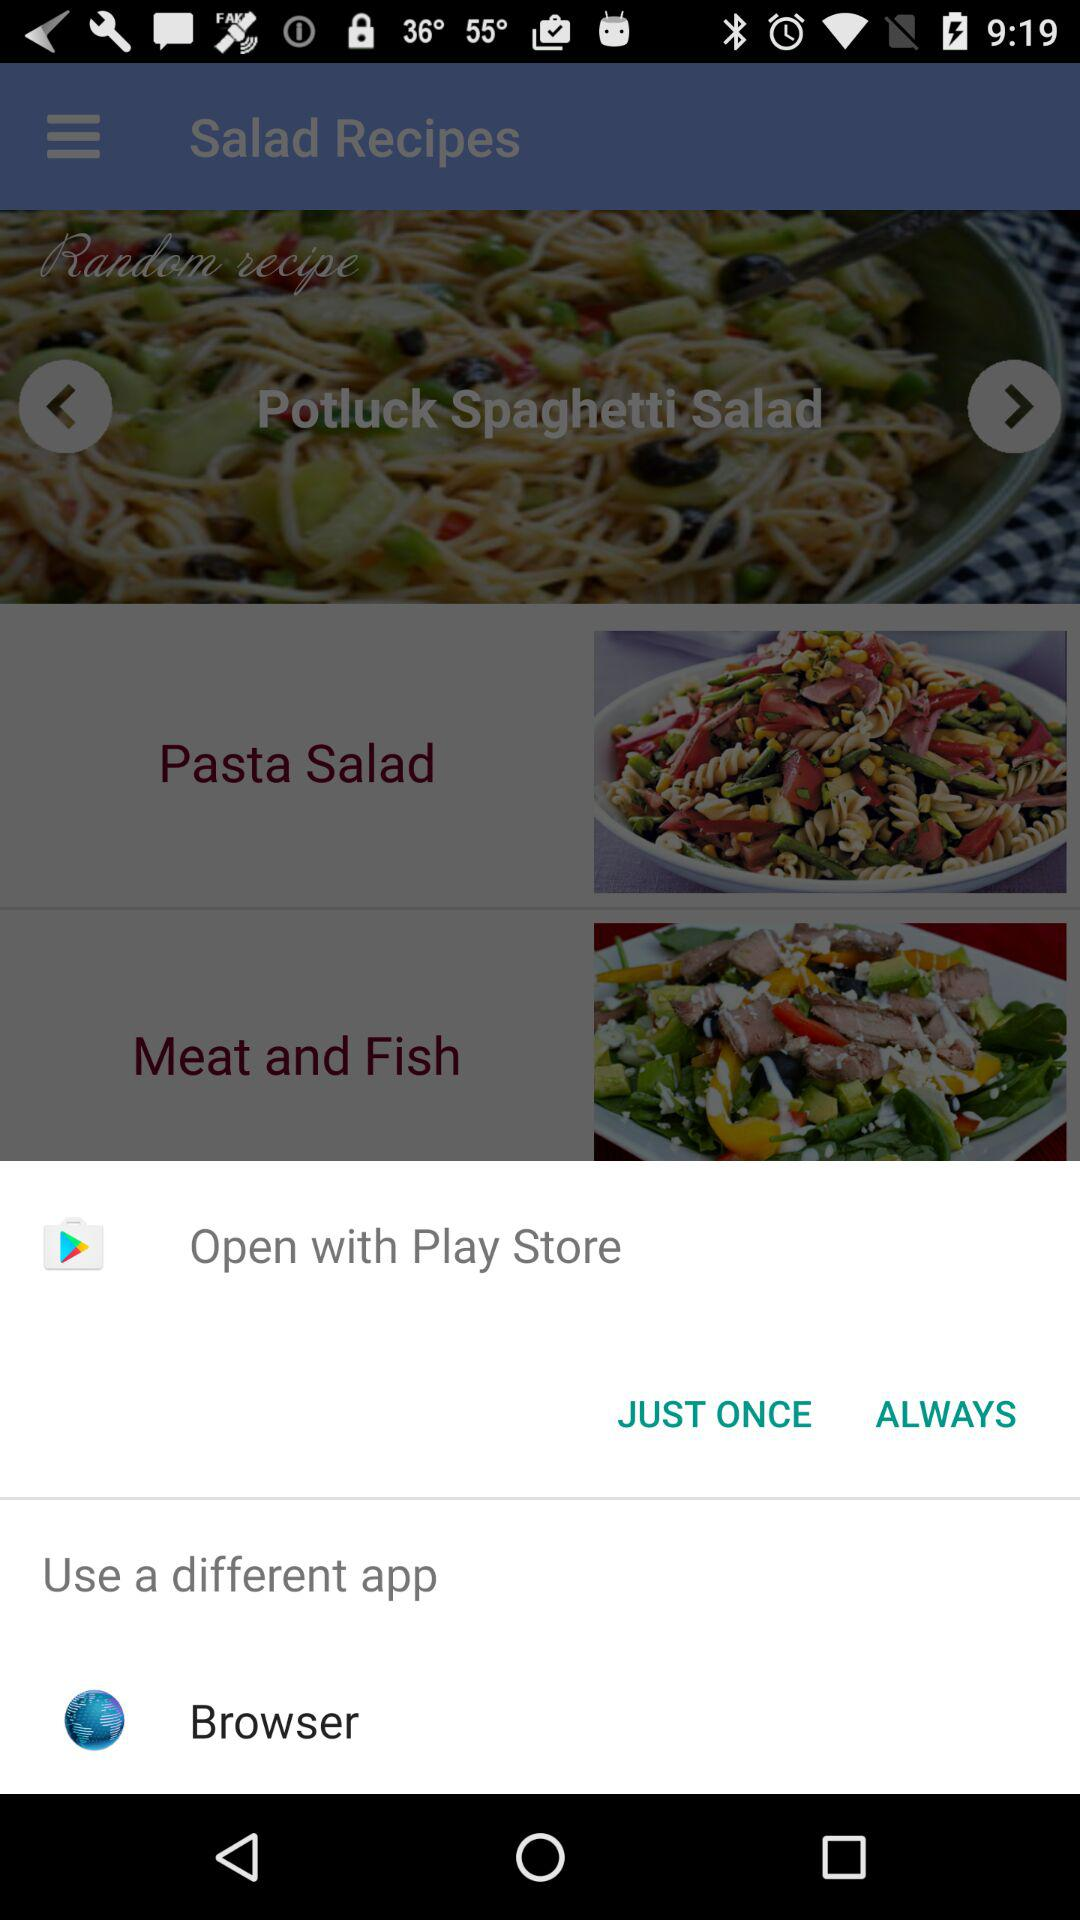Which application should I choose to open? You can open it with the Play Store. 